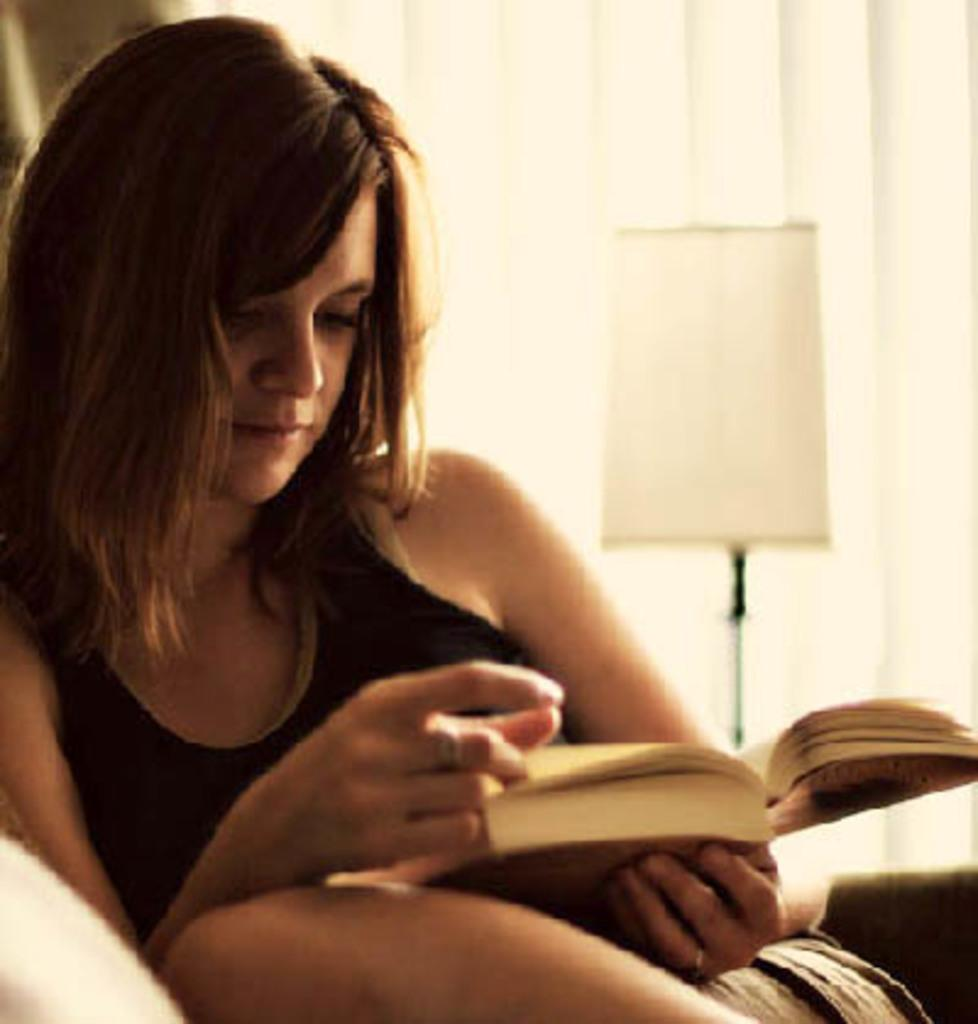Who is the main subject in the picture? There is a woman in the picture. What is the woman doing in the image? The woman is reading a book. Where is the woman sitting in the image? The woman is sitting on a couch. What other objects can be seen in the image? There is a lamp in the image, and it is placed near a window blind. Can you see any boats in the harbor in the image? There is no harbor or boats present in the image. Is the woman wearing a veil in the image? The woman is not wearing a veil in the image. 